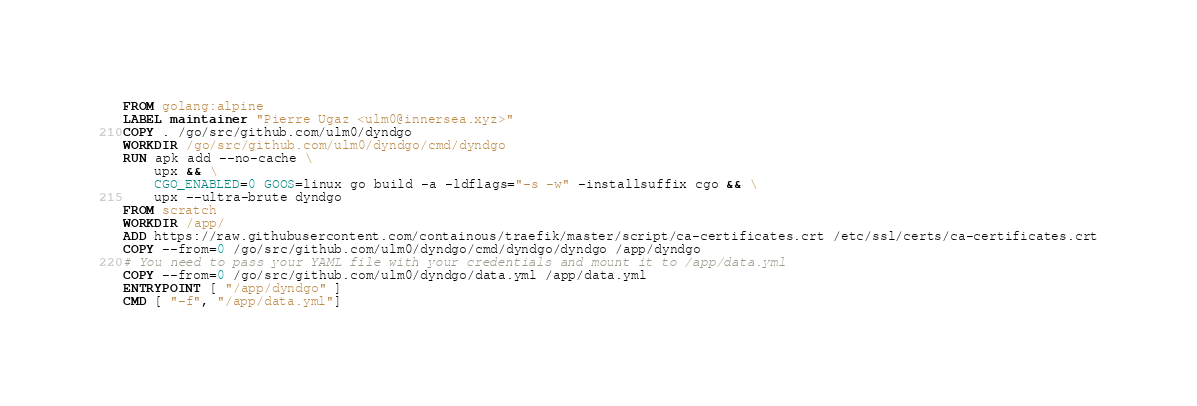<code> <loc_0><loc_0><loc_500><loc_500><_Dockerfile_>FROM golang:alpine
LABEL maintainer "Pierre Ugaz <ulm0@innersea.xyz>"
COPY . /go/src/github.com/ulm0/dyndgo
WORKDIR /go/src/github.com/ulm0/dyndgo/cmd/dyndgo
RUN apk add --no-cache \
    upx && \
    CGO_ENABLED=0 GOOS=linux go build -a -ldflags="-s -w" -installsuffix cgo && \
    upx --ultra-brute dyndgo
FROM scratch
WORKDIR /app/
ADD https://raw.githubusercontent.com/containous/traefik/master/script/ca-certificates.crt /etc/ssl/certs/ca-certificates.crt
COPY --from=0 /go/src/github.com/ulm0/dyndgo/cmd/dyndgo/dyndgo /app/dyndgo
# You need to pass your YAML file with your credentials and mount it to /app/data.yml
COPY --from=0 /go/src/github.com/ulm0/dyndgo/data.yml /app/data.yml
ENTRYPOINT [ "/app/dyndgo" ]
CMD [ "-f", "/app/data.yml"]
</code> 